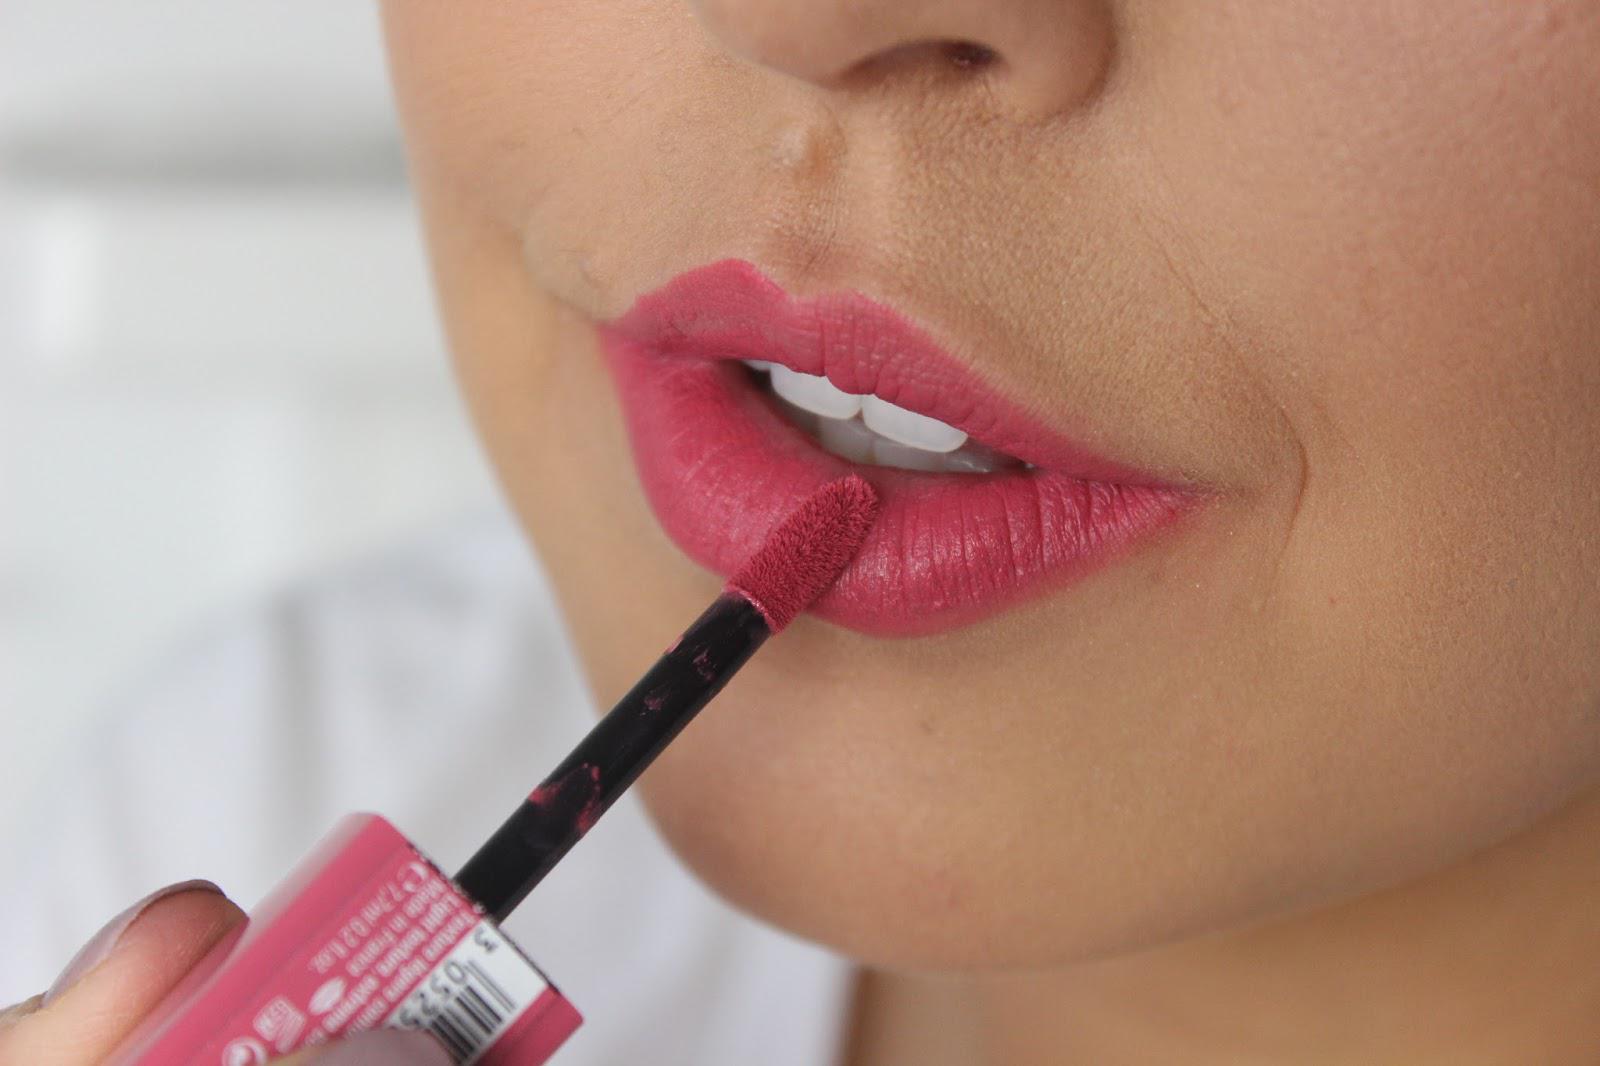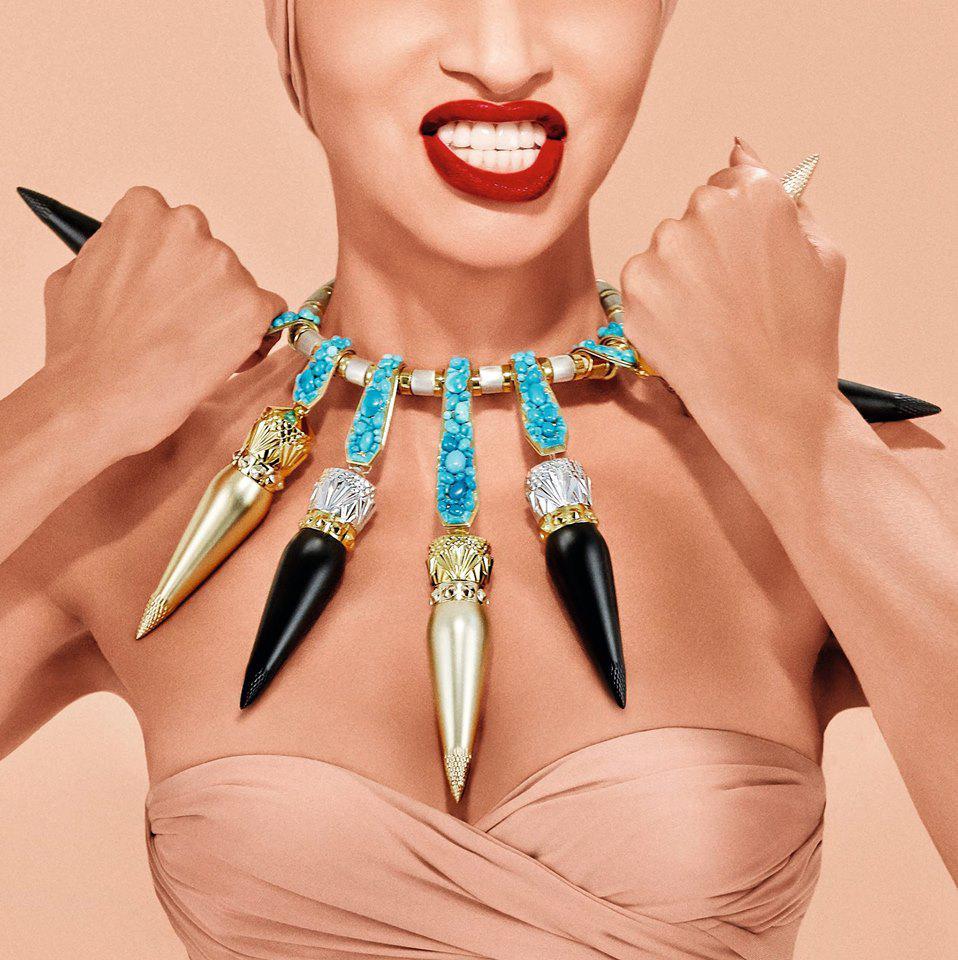The first image is the image on the left, the second image is the image on the right. For the images shown, is this caption "An image shows untinted and tinted lips under the face of a smiling model." true? Answer yes or no. No. The first image is the image on the left, the second image is the image on the right. Evaluate the accuracy of this statement regarding the images: "The right image contains a human wearing a large necklace.". Is it true? Answer yes or no. Yes. 